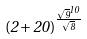<formula> <loc_0><loc_0><loc_500><loc_500>( 2 + 2 0 ) ^ { \frac { \sqrt { 9 } ^ { 1 0 } } { \sqrt { 8 } } }</formula> 